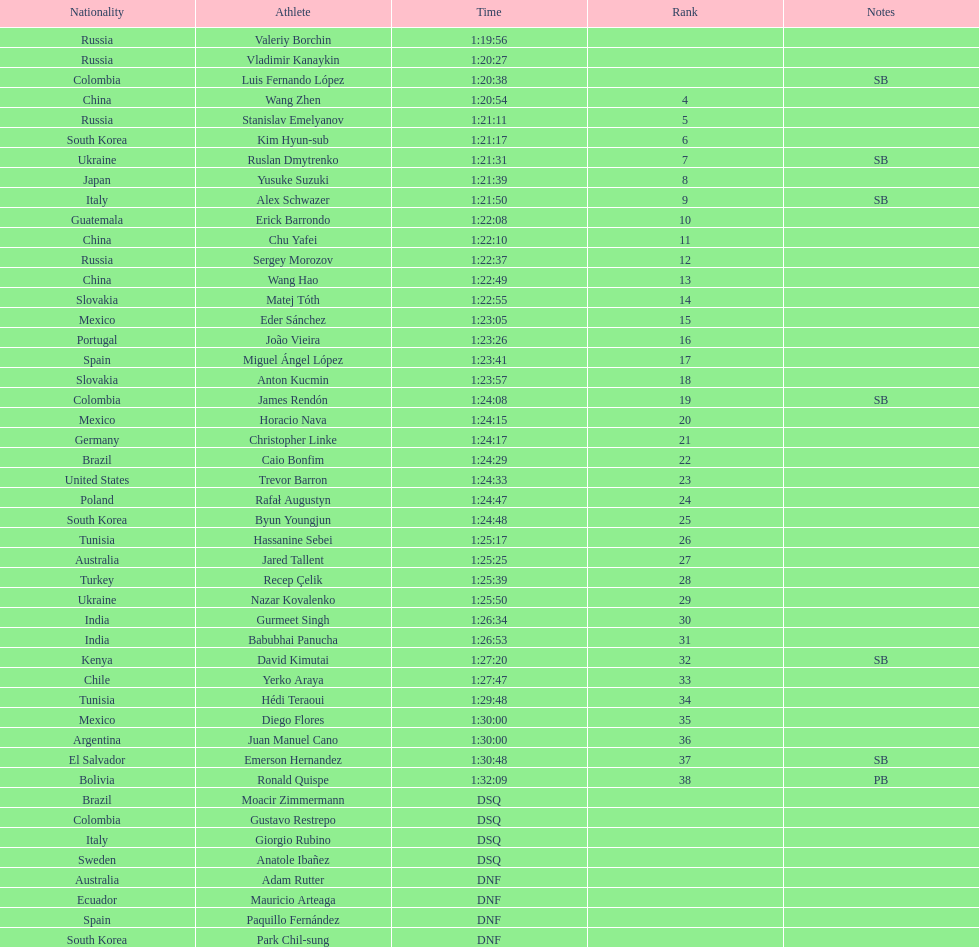How many russians finished at least 3rd in the 20km walk? 2. 